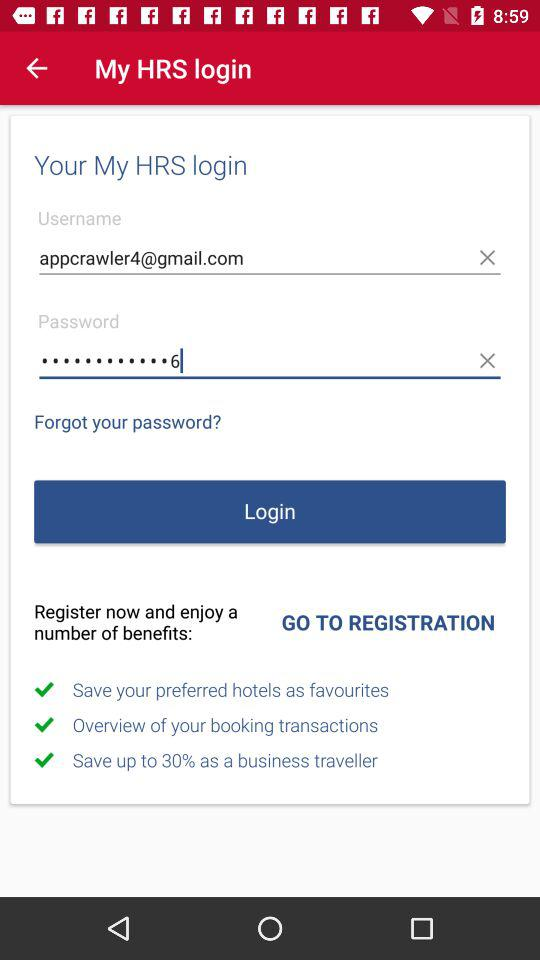How many text inputs are there for entering login credentials?
Answer the question using a single word or phrase. 2 